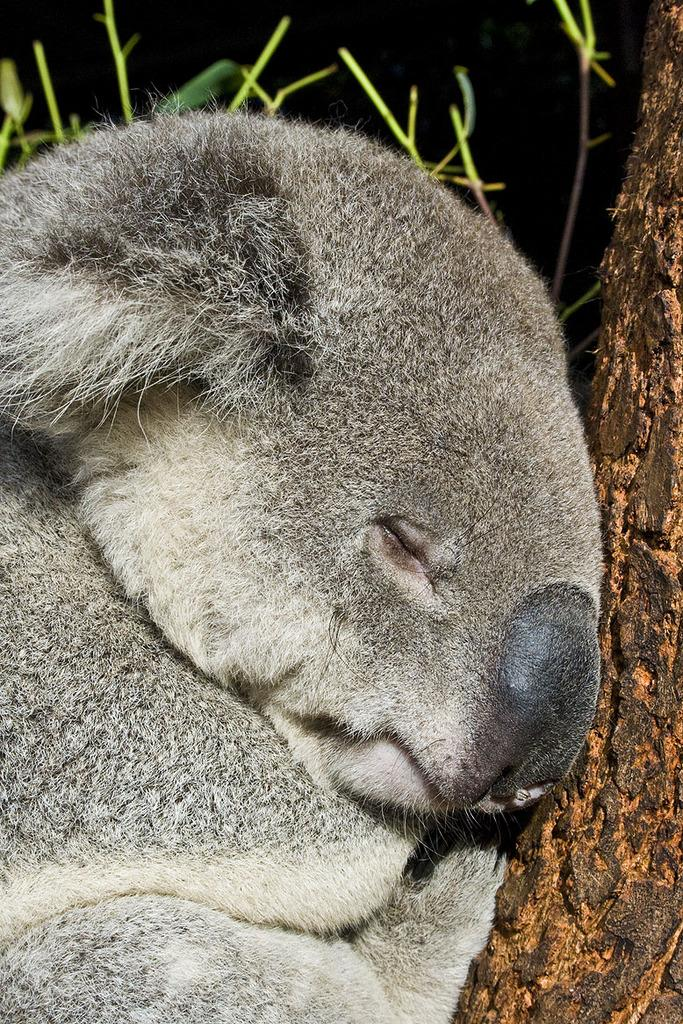What animal is the main subject of the image? There is a koala in the image. What is the koala positioned near in the image? The koala is near a wooden trunk. How would you describe the overall lighting in the image? The background of the image is dark. What type of plant elements can be seen in the image? There are stems visible in the image. What type of attraction is the koala visiting in the image? There is no indication in the image that the koala is visiting an attraction. Can you describe the scent of the pipe in the image? There is no pipe present in the image, so it is not possible to describe its scent. 